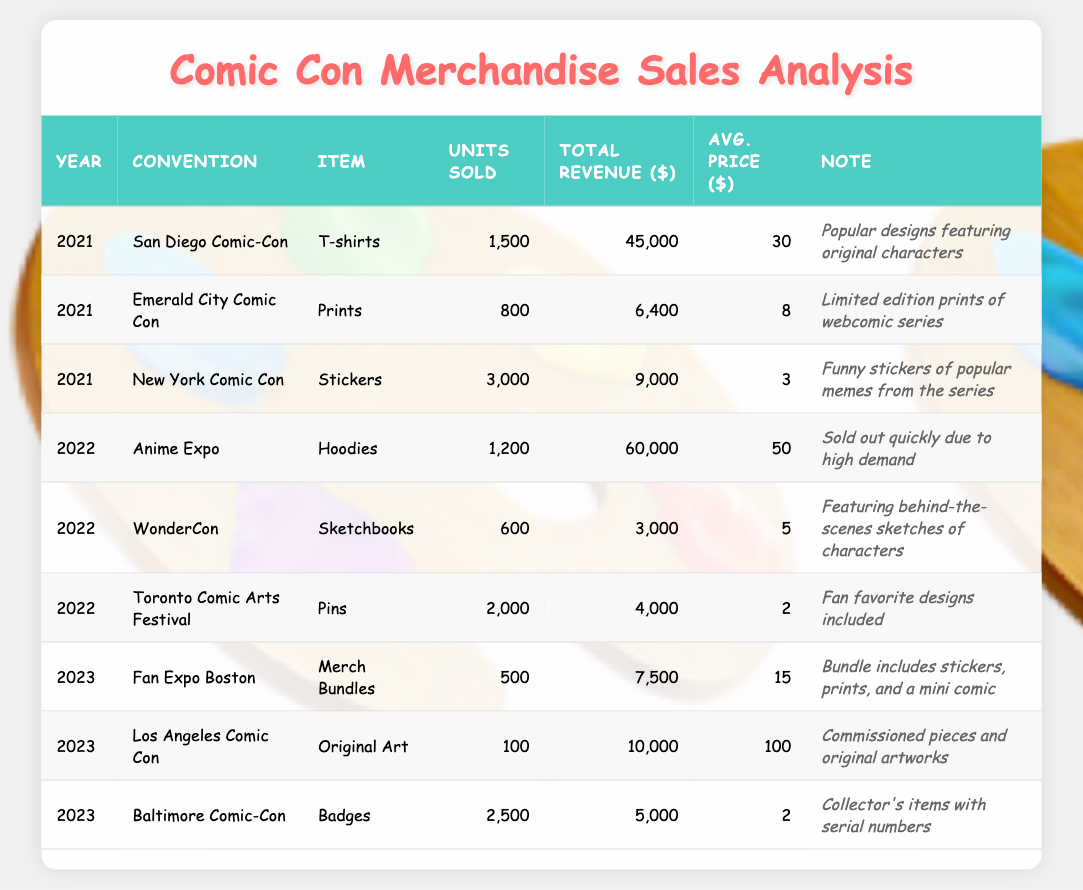What was the most sold item at the San Diego Comic-Con in 2021? The table shows that T-shirts were sold at the San Diego Comic-Con in 2021, with units sold being 1,500. This is the highest number of units sold compared to other items listed for that year.
Answer: T-shirts How many total units were sold across all conventions in 2022? In 2022, the units sold are 1,200 (Hoodies) + 600 (Sketchbooks) + 2,000 (Pins) = 3,800 units.
Answer: 3,800 Which item generated the highest total revenue in 2021? In 2021, T-shirts had a total revenue of $45,000, while Prints generated $6,400 and Stickers generated $9,000. T-shirts generated the highest revenue.
Answer: T-shirts How much total revenue was generated from badges in 2023? The table indicates that the total revenue from Badges at the Baltimore Comic-Con in 2023 was $5,000.
Answer: $5,000 What is the average price of items sold at the Anime Expo in 2022? At the Anime Expo in 2022, Hoodies were sold for $50, which is explicitly listed as the average price for that item.
Answer: $50 What was the total revenue difference between the best-selling item in 2022 and the best-selling item in 2021? The best-selling item in 2022 was Hoodies with $60,000 in revenue, and in 2021 it was T-shirts with $45,000. The difference is $60,000 - $45,000 = $15,000.
Answer: $15,000 Did more units of Stickers sell in 2021 compared to Pins sold in 2022? 3,000 Stickers were sold in 2021, while 2,000 Pins were sold in 2022, confirming that more Stickers were sold.
Answer: Yes What is the total number of units sold for Merch Bundles and Original Art in 2023? The total units sold for Merch Bundles were 500, and for Original Art it was 100, giving a combined total of 500 + 100 = 600 units sold.
Answer: 600 Which convention had the most diverse range of merchandise sales in terms of item variety? Analyzing the table shows that in 2022, three different items were sold at the major conventions: Hoodies, Sketchbooks, and Pins, compared to fewer items in other years or conventions.
Answer: 2022 How does the average price of T-shirts in 2021 compare to the average price of Hoodies in 2022? T-shirts had an average price of $30 in 2021, while Hoodies had an average price of $50 in 2022, demonstrating that Hoodies were sold at a higher average price.
Answer: Hoodies are more expensive 